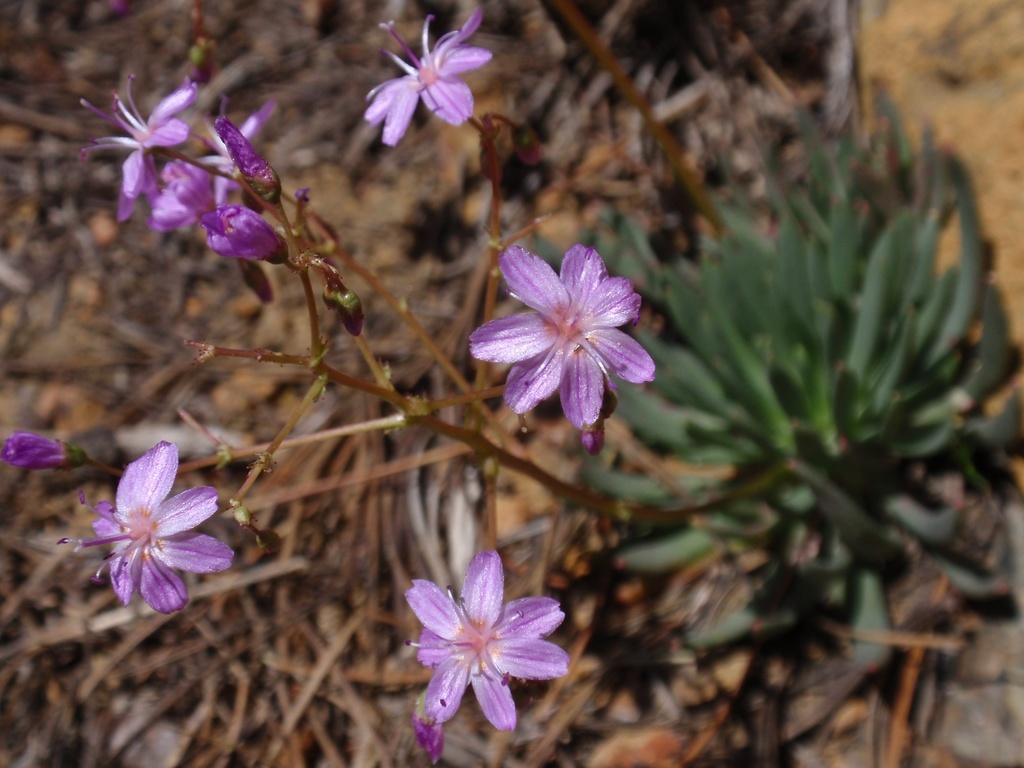Could you give a brief overview of what you see in this image? In this image we can see some plants and flowers which are in purple color, also we can see some wood. 